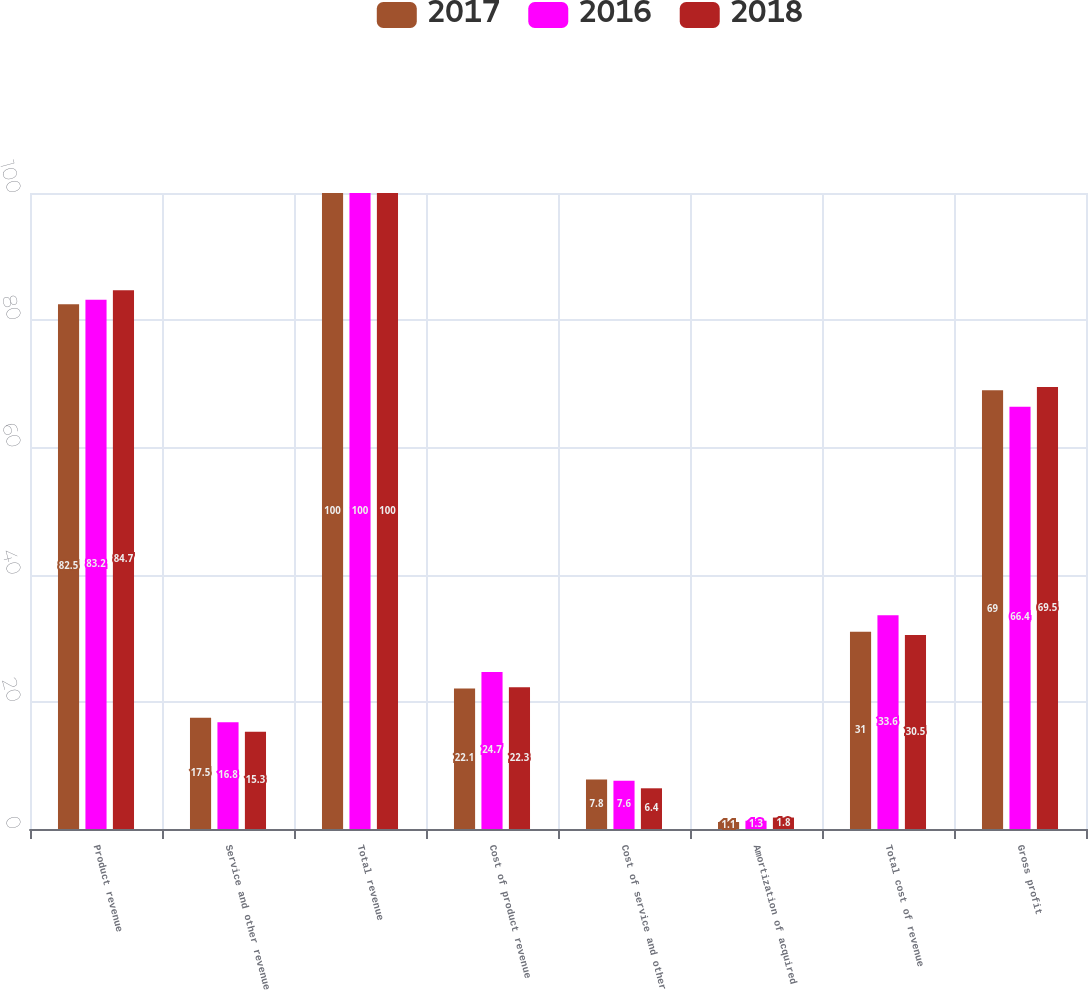<chart> <loc_0><loc_0><loc_500><loc_500><stacked_bar_chart><ecel><fcel>Product revenue<fcel>Service and other revenue<fcel>Total revenue<fcel>Cost of product revenue<fcel>Cost of service and other<fcel>Amortization of acquired<fcel>Total cost of revenue<fcel>Gross profit<nl><fcel>2017<fcel>82.5<fcel>17.5<fcel>100<fcel>22.1<fcel>7.8<fcel>1.1<fcel>31<fcel>69<nl><fcel>2016<fcel>83.2<fcel>16.8<fcel>100<fcel>24.7<fcel>7.6<fcel>1.3<fcel>33.6<fcel>66.4<nl><fcel>2018<fcel>84.7<fcel>15.3<fcel>100<fcel>22.3<fcel>6.4<fcel>1.8<fcel>30.5<fcel>69.5<nl></chart> 